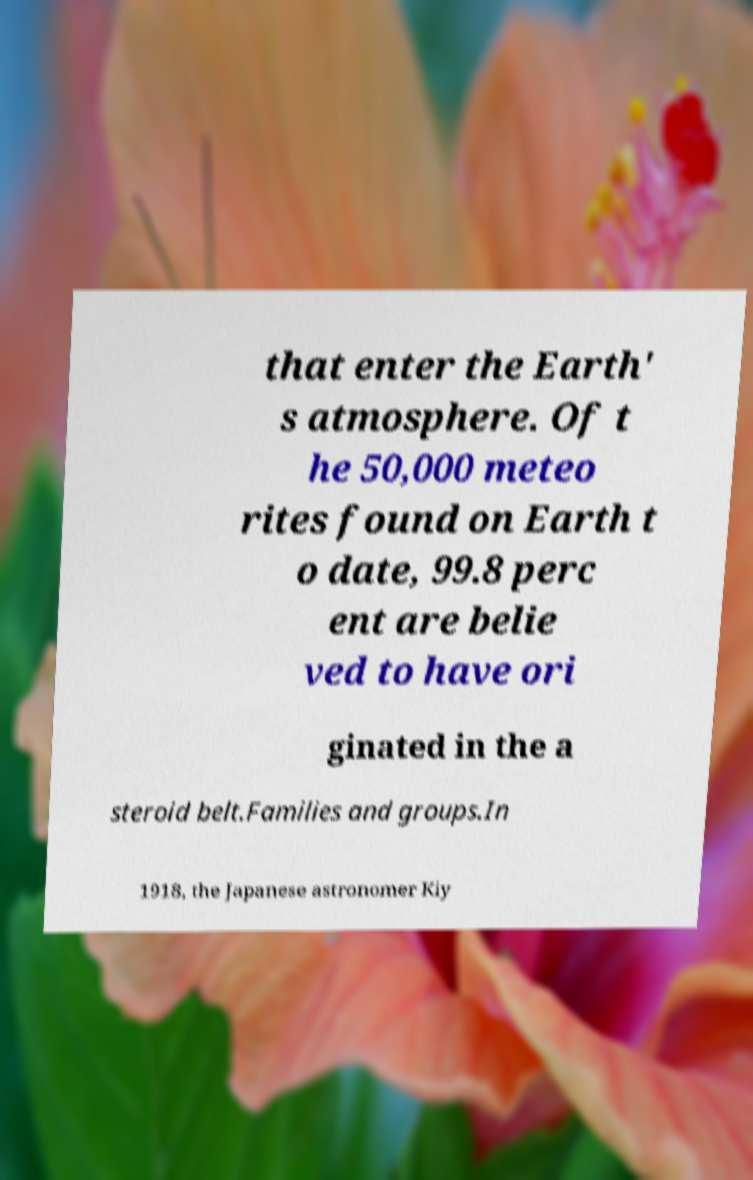Can you accurately transcribe the text from the provided image for me? that enter the Earth' s atmosphere. Of t he 50,000 meteo rites found on Earth t o date, 99.8 perc ent are belie ved to have ori ginated in the a steroid belt.Families and groups.In 1918, the Japanese astronomer Kiy 